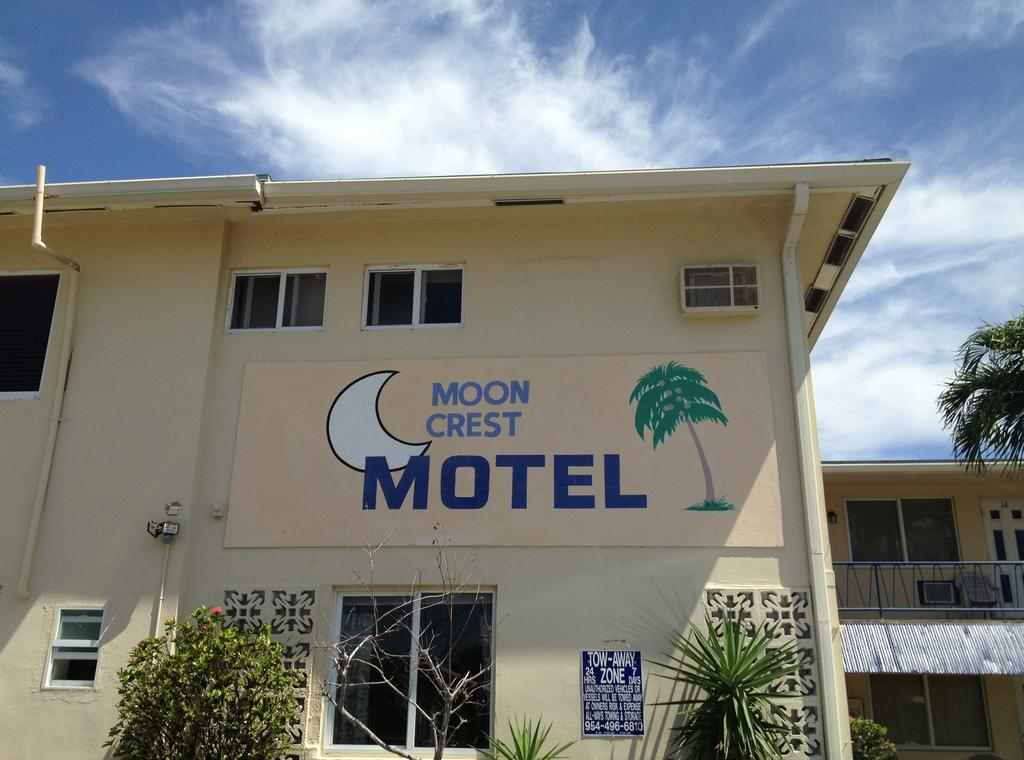What structure is depicted in the image? There is a building in the image. What is attached to the building? There is a poster on the building. What can be read on the poster? There is text on the poster. What type of vegetation is present in the image? There are plants in the image. What is visible at the top of the image? The sky is visible at the top of the image. What can be observed in the sky? Clouds are present in the sky. How many oranges are hanging from the building in the image? There are no oranges present in the image. What type of bath can be seen in the image? There is no bath present in the image. 